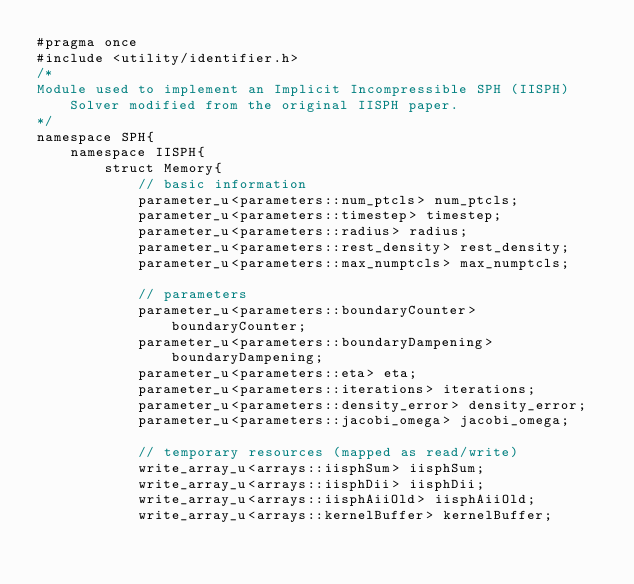<code> <loc_0><loc_0><loc_500><loc_500><_Cuda_>#pragma once
#include <utility/identifier.h>
/*
Module used to implement an Implicit Incompressible SPH (IISPH) Solver modified from the original IISPH paper.
*/
namespace SPH{
	namespace IISPH{
		struct Memory{
			// basic information
			parameter_u<parameters::num_ptcls> num_ptcls;
			parameter_u<parameters::timestep> timestep;
			parameter_u<parameters::radius> radius;
			parameter_u<parameters::rest_density> rest_density;
			parameter_u<parameters::max_numptcls> max_numptcls;

			// parameters
			parameter_u<parameters::boundaryCounter> boundaryCounter;
			parameter_u<parameters::boundaryDampening> boundaryDampening;
			parameter_u<parameters::eta> eta;
			parameter_u<parameters::iterations> iterations;
			parameter_u<parameters::density_error> density_error;
			parameter_u<parameters::jacobi_omega> jacobi_omega;

			// temporary resources (mapped as read/write)
			write_array_u<arrays::iisphSum> iisphSum;
			write_array_u<arrays::iisphDii> iisphDii;
			write_array_u<arrays::iisphAiiOld> iisphAiiOld;
			write_array_u<arrays::kernelBuffer> kernelBuffer;</code> 